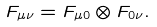Convert formula to latex. <formula><loc_0><loc_0><loc_500><loc_500>F _ { \mu \nu } = F _ { \mu 0 } \otimes F _ { 0 \nu } .</formula> 